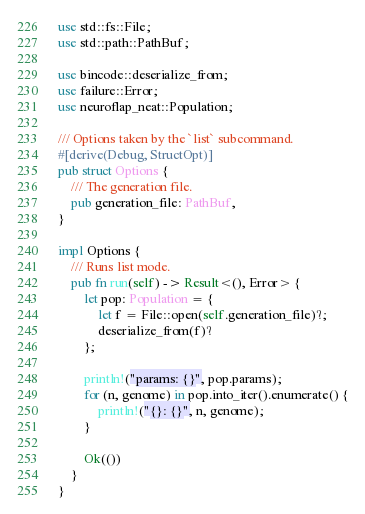<code> <loc_0><loc_0><loc_500><loc_500><_Rust_>use std::fs::File;
use std::path::PathBuf;

use bincode::deserialize_from;
use failure::Error;
use neuroflap_neat::Population;

/// Options taken by the `list` subcommand.
#[derive(Debug, StructOpt)]
pub struct Options {
    /// The generation file.
    pub generation_file: PathBuf,
}

impl Options {
    /// Runs list mode.
    pub fn run(self) -> Result<(), Error> {
        let pop: Population = {
            let f = File::open(self.generation_file)?;
            deserialize_from(f)?
        };

        println!("params: {}", pop.params);
        for (n, genome) in pop.into_iter().enumerate() {
            println!("{}: {}", n, genome);
        }

        Ok(())
    }
}
</code> 